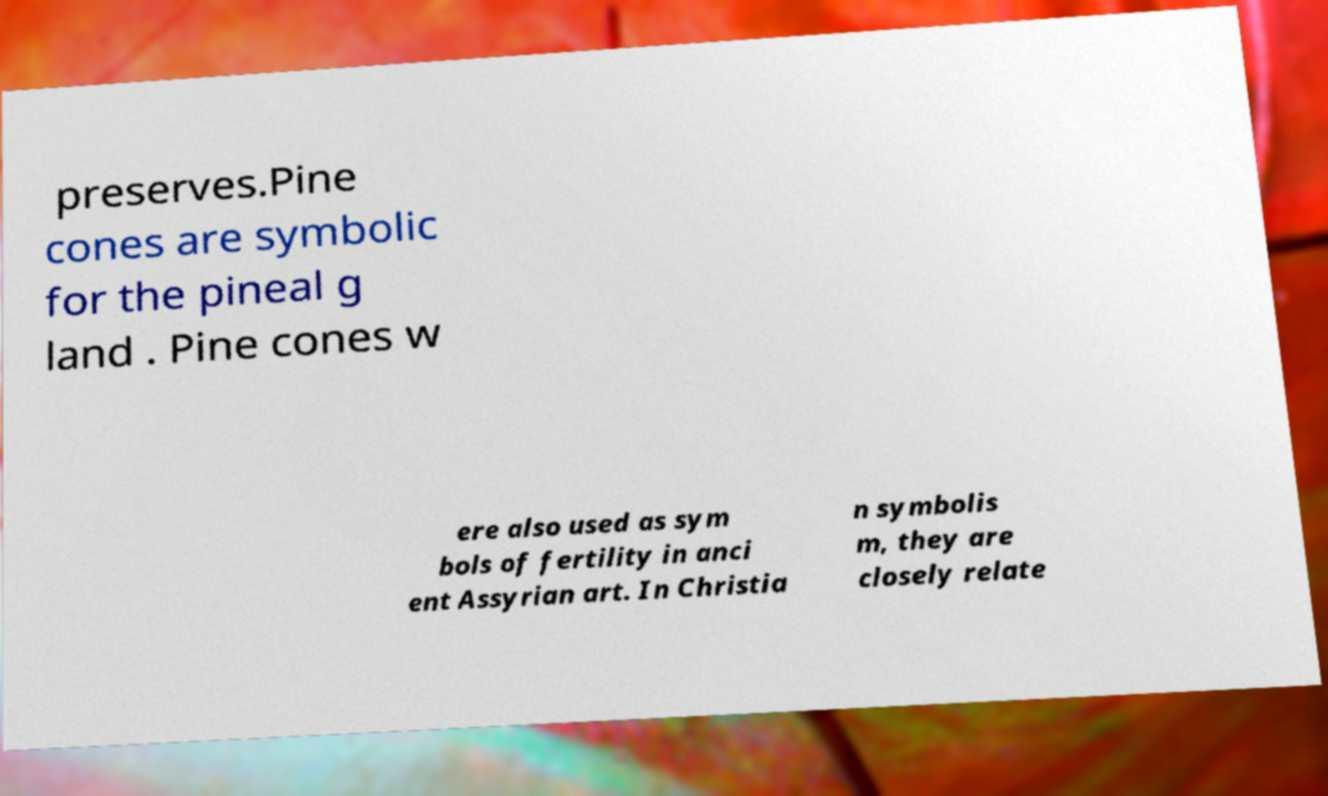Please identify and transcribe the text found in this image. preserves.Pine cones are symbolic for the pineal g land . Pine cones w ere also used as sym bols of fertility in anci ent Assyrian art. In Christia n symbolis m, they are closely relate 